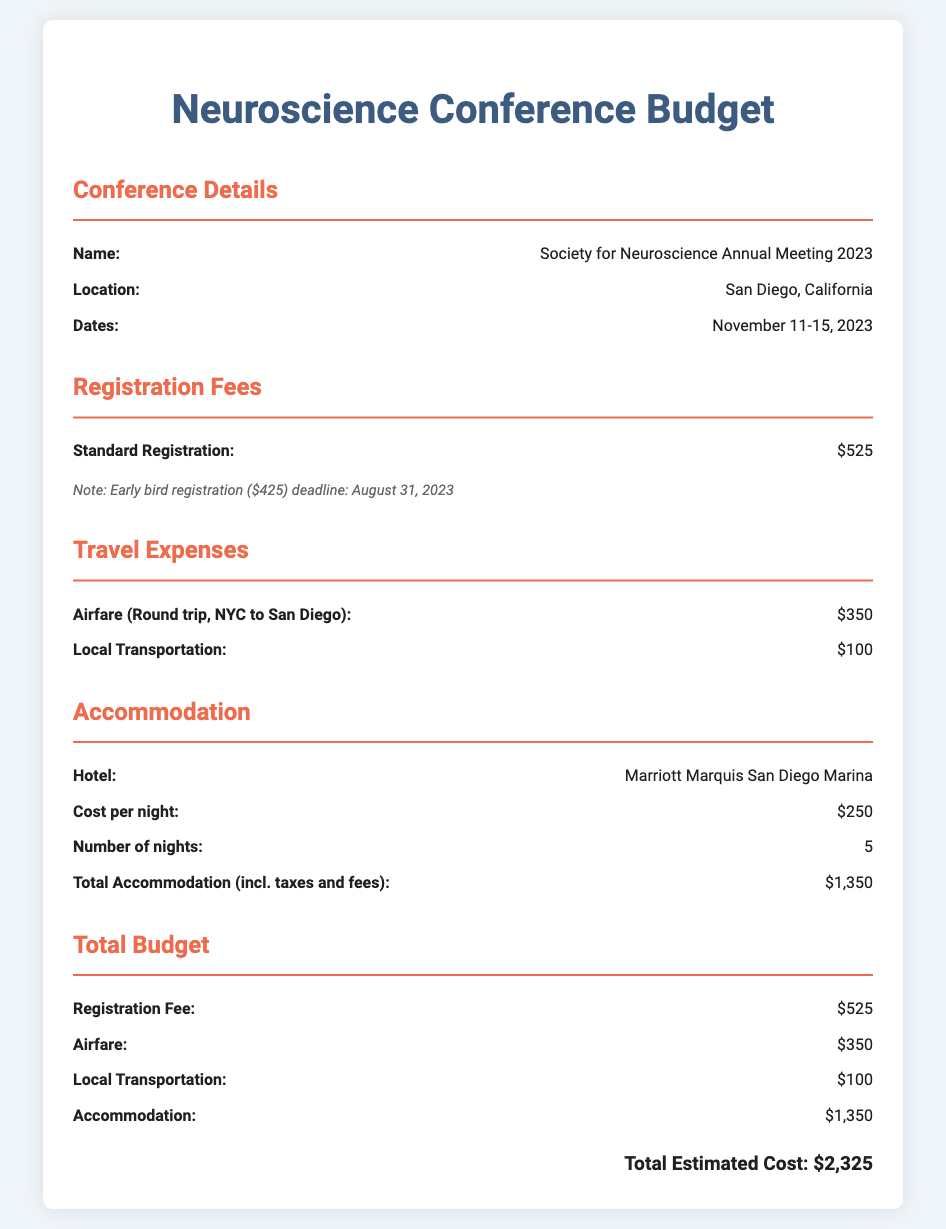What is the name of the conference? The conference name is provided in the document as "Society for Neuroscience Annual Meeting 2023."
Answer: Society for Neuroscience Annual Meeting 2023 Where is the conference being held? The location of the conference is mentioned as "San Diego, California."
Answer: San Diego, California What are the dates of the conference? The dates for the conference are specified in the document as "November 11-15, 2023."
Answer: November 11-15, 2023 What is the standard registration fee? The document states that the standard registration fee is "$525."
Answer: $525 How much is the airfare for the round trip? The airfare for the round trip is indicated as "$350."
Answer: $350 What is the total estimated cost for the conference attendance? The total estimated cost is the sum of registration fee, airfare, transportation, and accommodation, calculated in the budget as "$2,325."
Answer: $2,325 How many nights will the accommodation be booked? The document specifies that the accommodation will be booked for "5" nights.
Answer: 5 What is the cost per night for the hotel? The cost per night for the hotel is mentioned as "$250."
Answer: $250 What is included in the total accommodation cost? The total accommodation cost includes nightly rates and associated taxes and fees as stated in the document.
Answer: Total Accommodation (incl. taxes and fees) $1,350 